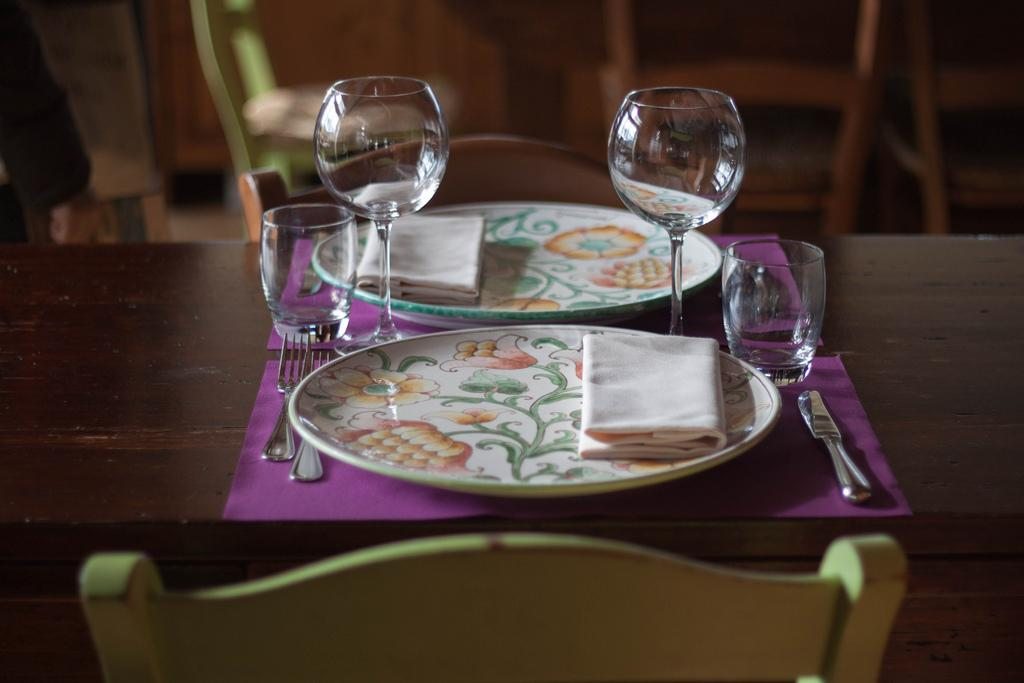What piece of furniture is present in the image? There is a table in the image. What items are on the table? There are two plates, glasses, cups, and spoons on the table. What type of seating is visible in the image? There are chairs in the image. What type of pear is being used as a soap in the image? There is no pear or soap present in the image. What belief is being represented by the objects in the image? The image does not depict any beliefs or symbolism; it simply shows a table with various items on it. 